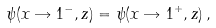<formula> <loc_0><loc_0><loc_500><loc_500>\psi ( x \rightarrow 1 ^ { - } , z ) = \psi ( x \rightarrow 1 ^ { + } , z ) \, ,</formula> 